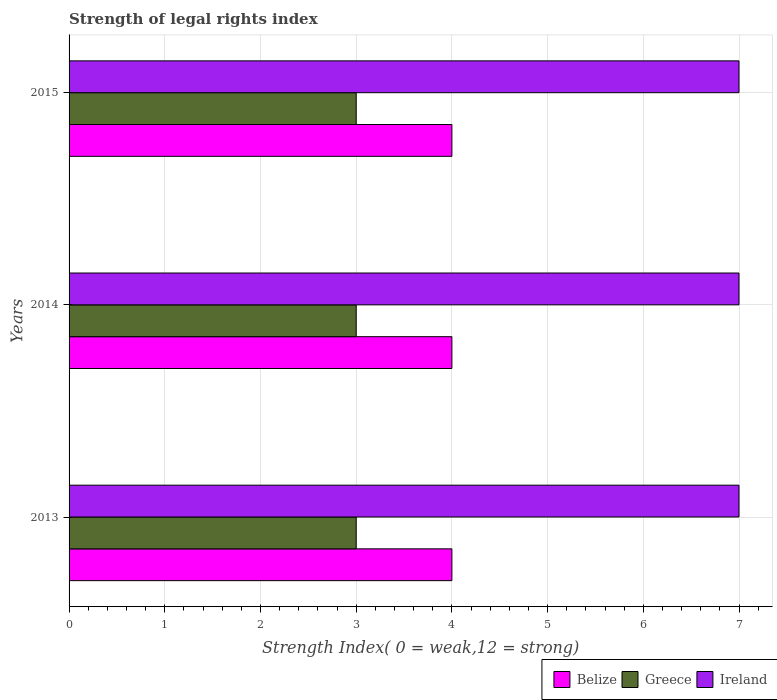How many different coloured bars are there?
Make the answer very short. 3. How many groups of bars are there?
Your response must be concise. 3. Are the number of bars per tick equal to the number of legend labels?
Offer a very short reply. Yes. Are the number of bars on each tick of the Y-axis equal?
Keep it short and to the point. Yes. What is the label of the 1st group of bars from the top?
Offer a terse response. 2015. What is the strength index in Greece in 2015?
Give a very brief answer. 3. Across all years, what is the maximum strength index in Greece?
Your response must be concise. 3. Across all years, what is the minimum strength index in Greece?
Your answer should be very brief. 3. In which year was the strength index in Greece minimum?
Provide a short and direct response. 2013. What is the total strength index in Greece in the graph?
Your response must be concise. 9. What is the difference between the strength index in Belize in 2013 and the strength index in Ireland in 2015?
Your answer should be compact. -3. What is the average strength index in Belize per year?
Provide a short and direct response. 4. In the year 2013, what is the difference between the strength index in Ireland and strength index in Belize?
Ensure brevity in your answer.  3. In how many years, is the strength index in Belize greater than 6.4 ?
Provide a short and direct response. 0. What is the ratio of the strength index in Greece in 2014 to that in 2015?
Your answer should be very brief. 1. Is the strength index in Greece in 2014 less than that in 2015?
Your response must be concise. No. Is the difference between the strength index in Ireland in 2014 and 2015 greater than the difference between the strength index in Belize in 2014 and 2015?
Make the answer very short. No. What is the difference between the highest and the lowest strength index in Greece?
Your answer should be compact. 0. In how many years, is the strength index in Belize greater than the average strength index in Belize taken over all years?
Your response must be concise. 0. What does the 2nd bar from the top in 2015 represents?
Provide a succinct answer. Greece. What does the 3rd bar from the bottom in 2013 represents?
Your answer should be very brief. Ireland. Are all the bars in the graph horizontal?
Provide a short and direct response. Yes. How many years are there in the graph?
Offer a very short reply. 3. Does the graph contain any zero values?
Offer a terse response. No. Where does the legend appear in the graph?
Keep it short and to the point. Bottom right. How are the legend labels stacked?
Offer a very short reply. Horizontal. What is the title of the graph?
Keep it short and to the point. Strength of legal rights index. Does "Russian Federation" appear as one of the legend labels in the graph?
Your answer should be compact. No. What is the label or title of the X-axis?
Ensure brevity in your answer.  Strength Index( 0 = weak,12 = strong). What is the label or title of the Y-axis?
Give a very brief answer. Years. What is the Strength Index( 0 = weak,12 = strong) in Belize in 2013?
Provide a short and direct response. 4. What is the Strength Index( 0 = weak,12 = strong) in Greece in 2013?
Your answer should be very brief. 3. What is the Strength Index( 0 = weak,12 = strong) of Belize in 2014?
Your answer should be compact. 4. What is the Strength Index( 0 = weak,12 = strong) in Ireland in 2014?
Your answer should be compact. 7. What is the Strength Index( 0 = weak,12 = strong) of Belize in 2015?
Your answer should be compact. 4. What is the Strength Index( 0 = weak,12 = strong) of Ireland in 2015?
Provide a short and direct response. 7. Across all years, what is the maximum Strength Index( 0 = weak,12 = strong) in Greece?
Your answer should be compact. 3. Across all years, what is the maximum Strength Index( 0 = weak,12 = strong) in Ireland?
Ensure brevity in your answer.  7. Across all years, what is the minimum Strength Index( 0 = weak,12 = strong) in Belize?
Your answer should be compact. 4. What is the total Strength Index( 0 = weak,12 = strong) in Belize in the graph?
Your response must be concise. 12. What is the total Strength Index( 0 = weak,12 = strong) in Greece in the graph?
Provide a short and direct response. 9. What is the total Strength Index( 0 = weak,12 = strong) of Ireland in the graph?
Your response must be concise. 21. What is the difference between the Strength Index( 0 = weak,12 = strong) of Belize in 2013 and that in 2014?
Ensure brevity in your answer.  0. What is the difference between the Strength Index( 0 = weak,12 = strong) of Belize in 2013 and that in 2015?
Provide a short and direct response. 0. What is the difference between the Strength Index( 0 = weak,12 = strong) of Greece in 2013 and that in 2015?
Make the answer very short. 0. What is the difference between the Strength Index( 0 = weak,12 = strong) in Belize in 2014 and that in 2015?
Give a very brief answer. 0. What is the difference between the Strength Index( 0 = weak,12 = strong) in Ireland in 2014 and that in 2015?
Provide a succinct answer. 0. What is the difference between the Strength Index( 0 = weak,12 = strong) of Belize in 2013 and the Strength Index( 0 = weak,12 = strong) of Greece in 2014?
Provide a short and direct response. 1. What is the difference between the Strength Index( 0 = weak,12 = strong) of Belize in 2013 and the Strength Index( 0 = weak,12 = strong) of Greece in 2015?
Your response must be concise. 1. What is the difference between the Strength Index( 0 = weak,12 = strong) of Greece in 2014 and the Strength Index( 0 = weak,12 = strong) of Ireland in 2015?
Keep it short and to the point. -4. What is the average Strength Index( 0 = weak,12 = strong) in Ireland per year?
Your response must be concise. 7. In the year 2013, what is the difference between the Strength Index( 0 = weak,12 = strong) of Belize and Strength Index( 0 = weak,12 = strong) of Greece?
Your answer should be very brief. 1. In the year 2013, what is the difference between the Strength Index( 0 = weak,12 = strong) of Greece and Strength Index( 0 = weak,12 = strong) of Ireland?
Offer a terse response. -4. What is the ratio of the Strength Index( 0 = weak,12 = strong) in Greece in 2013 to that in 2014?
Provide a succinct answer. 1. What is the ratio of the Strength Index( 0 = weak,12 = strong) of Ireland in 2013 to that in 2014?
Offer a very short reply. 1. What is the ratio of the Strength Index( 0 = weak,12 = strong) of Belize in 2013 to that in 2015?
Ensure brevity in your answer.  1. What is the ratio of the Strength Index( 0 = weak,12 = strong) in Greece in 2013 to that in 2015?
Offer a very short reply. 1. What is the ratio of the Strength Index( 0 = weak,12 = strong) in Belize in 2014 to that in 2015?
Make the answer very short. 1. What is the ratio of the Strength Index( 0 = weak,12 = strong) in Greece in 2014 to that in 2015?
Offer a very short reply. 1. What is the difference between the highest and the second highest Strength Index( 0 = weak,12 = strong) in Belize?
Offer a terse response. 0. What is the difference between the highest and the second highest Strength Index( 0 = weak,12 = strong) of Greece?
Make the answer very short. 0. 